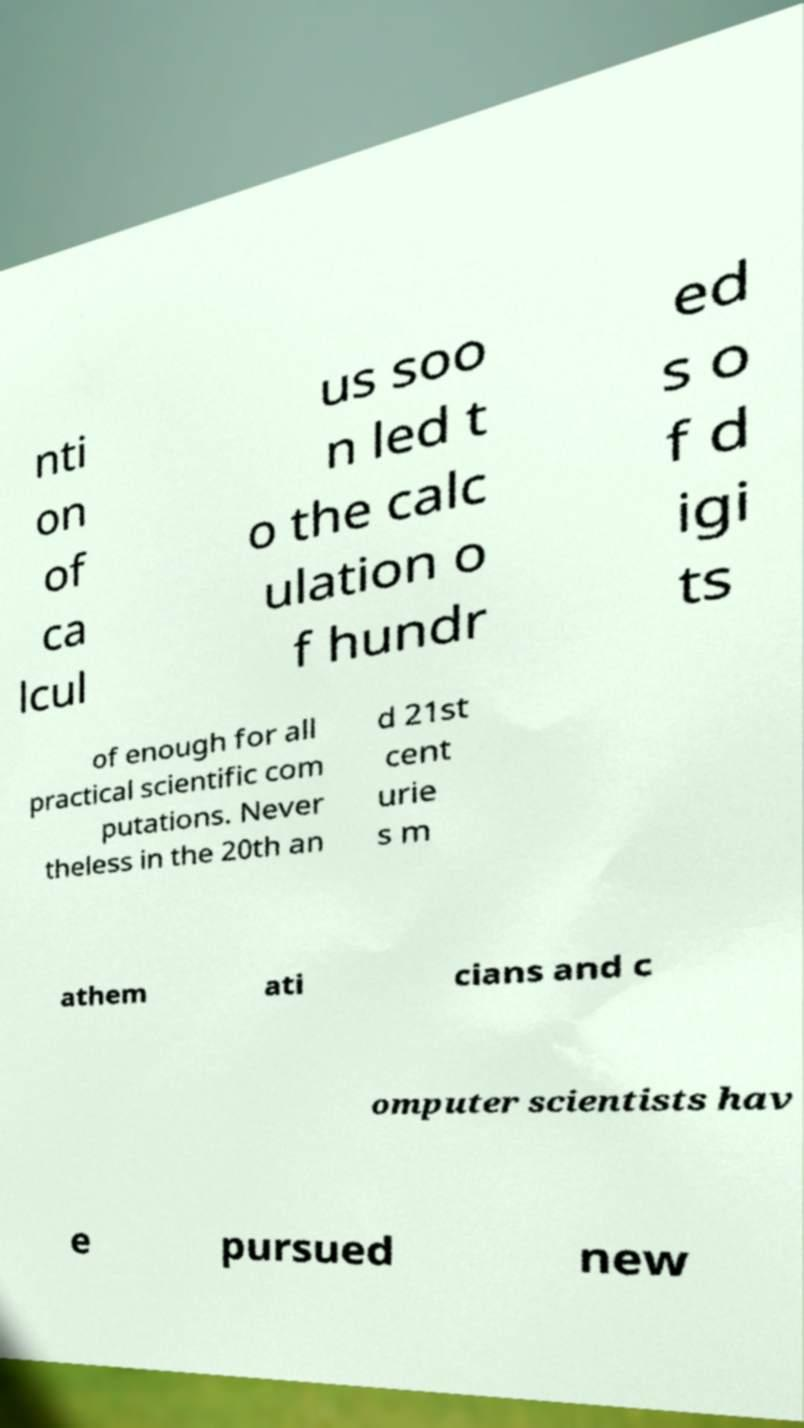Please read and relay the text visible in this image. What does it say? nti on of ca lcul us soo n led t o the calc ulation o f hundr ed s o f d igi ts of enough for all practical scientific com putations. Never theless in the 20th an d 21st cent urie s m athem ati cians and c omputer scientists hav e pursued new 